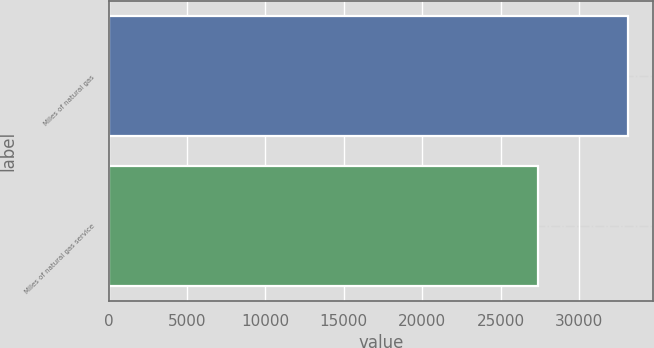<chart> <loc_0><loc_0><loc_500><loc_500><bar_chart><fcel>Miles of natural gas<fcel>Miles of natural gas service<nl><fcel>33100<fcel>27400<nl></chart> 